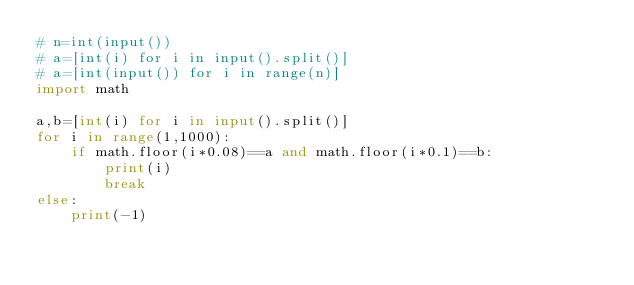<code> <loc_0><loc_0><loc_500><loc_500><_Python_># n=int(input())
# a=[int(i) for i in input().split()]
# a=[int(input()) for i in range(n)]
import math

a,b=[int(i) for i in input().split()]
for i in range(1,1000):
    if math.floor(i*0.08)==a and math.floor(i*0.1)==b:
        print(i)
        break
else:
    print(-1)</code> 